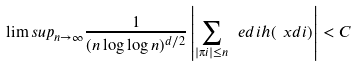Convert formula to latex. <formula><loc_0><loc_0><loc_500><loc_500>\lim s u p _ { n \to \infty } \frac { 1 } { ( n \log \log n ) ^ { d / 2 } } \left | \sum _ { | \i i | \leq n } \ e d i h ( \ x d i ) \right | < C</formula> 